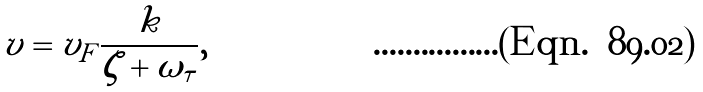<formula> <loc_0><loc_0><loc_500><loc_500>v = v _ { F } \frac { k } { \zeta + \omega _ { \tau } } ,</formula> 